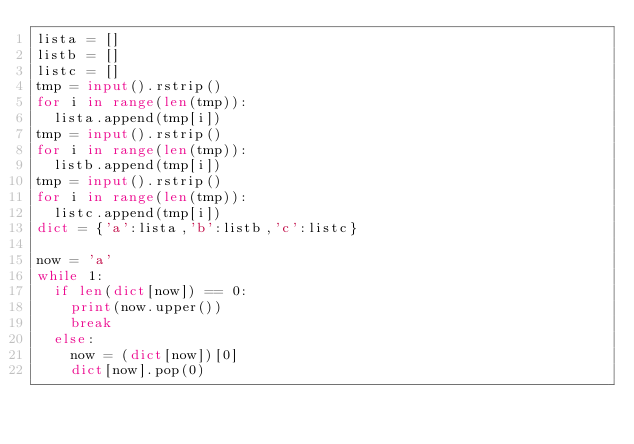Convert code to text. <code><loc_0><loc_0><loc_500><loc_500><_Python_>lista = []
listb = []
listc = []
tmp = input().rstrip()
for i in range(len(tmp)):
  lista.append(tmp[i])
tmp = input().rstrip()
for i in range(len(tmp)):
  listb.append(tmp[i])
tmp = input().rstrip()
for i in range(len(tmp)):
  listc.append(tmp[i])
dict = {'a':lista,'b':listb,'c':listc}

now = 'a'
while 1:
  if len(dict[now]) == 0:
    print(now.upper())
    break
  else:
    now = (dict[now])[0]
    dict[now].pop(0)</code> 